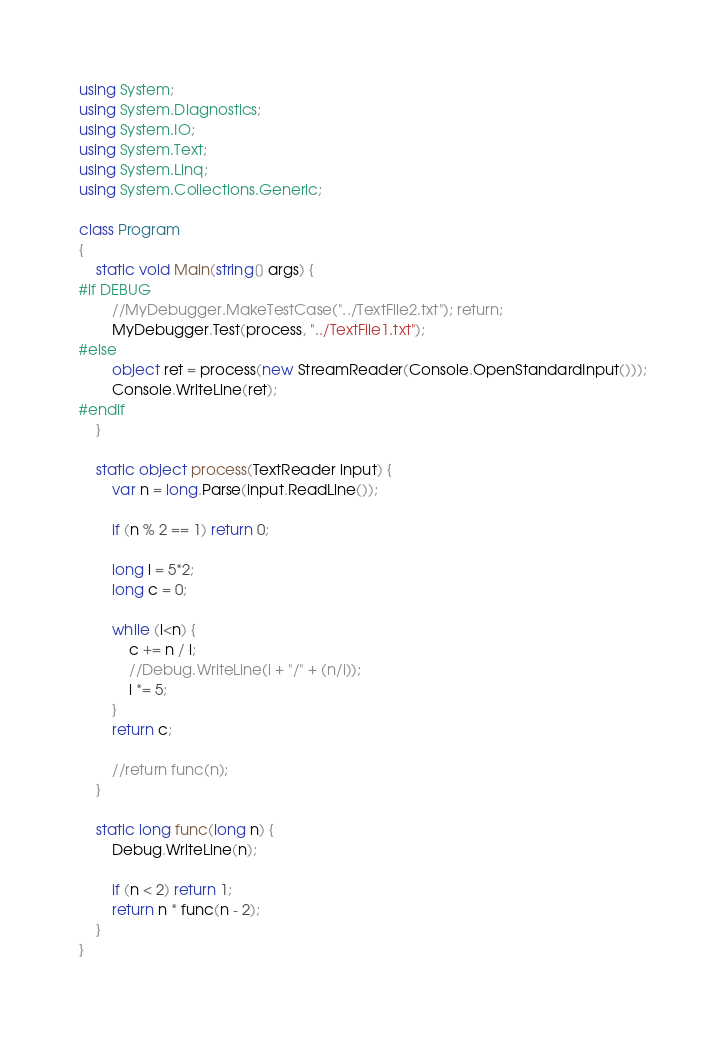<code> <loc_0><loc_0><loc_500><loc_500><_C#_>using System;
using System.Diagnostics;
using System.IO;
using System.Text;
using System.Linq;
using System.Collections.Generic;

class Program
{
    static void Main(string[] args) {
#if DEBUG
        //MyDebugger.MakeTestCase("../TextFile2.txt"); return;
        MyDebugger.Test(process, "../TextFile1.txt");
#else
        object ret = process(new StreamReader(Console.OpenStandardInput()));
        Console.WriteLine(ret);
#endif
    }

    static object process(TextReader input) {
        var n = long.Parse(input.ReadLine());

        if (n % 2 == 1) return 0;

        long i = 5*2;
        long c = 0;

        while (i<n) {
            c += n / i;
            //Debug.WriteLine(i + "/" + (n/i));
            i *= 5;
        }
        return c;

        //return func(n);
    }
    
    static long func(long n) {
        Debug.WriteLine(n);

        if (n < 2) return 1;
        return n * func(n - 2);
    }
}
</code> 